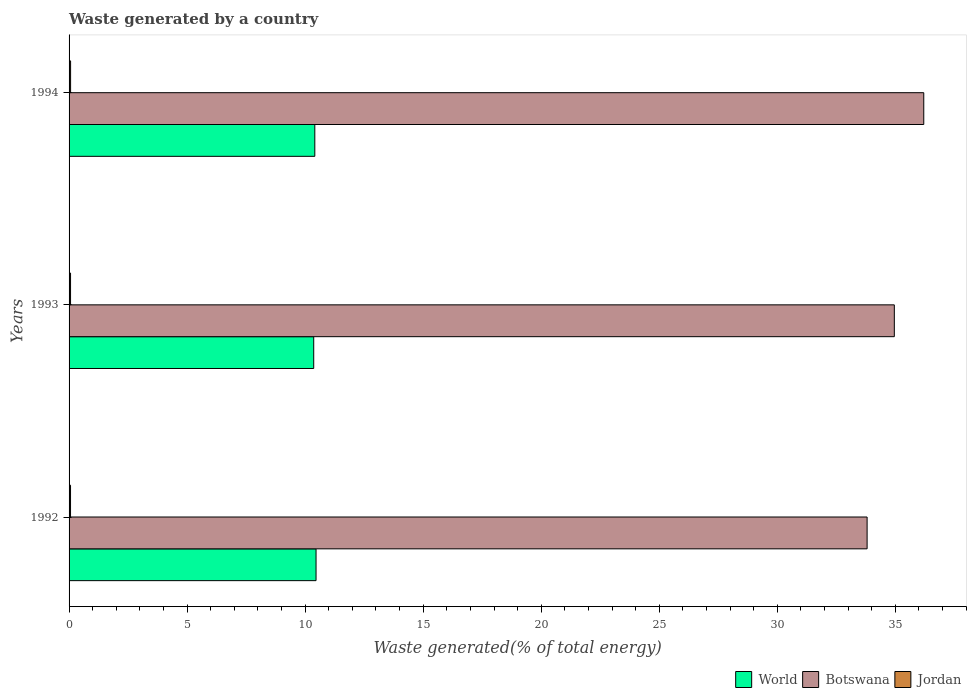Are the number of bars on each tick of the Y-axis equal?
Your answer should be compact. Yes. What is the label of the 2nd group of bars from the top?
Offer a very short reply. 1993. In how many cases, is the number of bars for a given year not equal to the number of legend labels?
Your response must be concise. 0. What is the total waste generated in Jordan in 1992?
Offer a very short reply. 0.06. Across all years, what is the maximum total waste generated in World?
Offer a very short reply. 10.46. Across all years, what is the minimum total waste generated in World?
Ensure brevity in your answer.  10.36. In which year was the total waste generated in Jordan maximum?
Give a very brief answer. 1994. What is the total total waste generated in World in the graph?
Provide a succinct answer. 31.23. What is the difference between the total waste generated in Jordan in 1993 and that in 1994?
Your response must be concise. -0. What is the difference between the total waste generated in Jordan in 1992 and the total waste generated in Botswana in 1993?
Give a very brief answer. -34.89. What is the average total waste generated in Botswana per year?
Offer a very short reply. 34.99. In the year 1994, what is the difference between the total waste generated in Jordan and total waste generated in World?
Make the answer very short. -10.34. What is the ratio of the total waste generated in Botswana in 1993 to that in 1994?
Give a very brief answer. 0.97. Is the total waste generated in Jordan in 1992 less than that in 1994?
Offer a very short reply. Yes. What is the difference between the highest and the second highest total waste generated in Jordan?
Provide a succinct answer. 0. What is the difference between the highest and the lowest total waste generated in World?
Your response must be concise. 0.1. In how many years, is the total waste generated in Botswana greater than the average total waste generated in Botswana taken over all years?
Make the answer very short. 1. What does the 3rd bar from the top in 1993 represents?
Make the answer very short. World. What does the 1st bar from the bottom in 1994 represents?
Make the answer very short. World. Is it the case that in every year, the sum of the total waste generated in World and total waste generated in Botswana is greater than the total waste generated in Jordan?
Offer a terse response. Yes. Are all the bars in the graph horizontal?
Provide a succinct answer. Yes. How many years are there in the graph?
Give a very brief answer. 3. Does the graph contain any zero values?
Make the answer very short. No. How are the legend labels stacked?
Make the answer very short. Horizontal. What is the title of the graph?
Make the answer very short. Waste generated by a country. Does "West Bank and Gaza" appear as one of the legend labels in the graph?
Offer a terse response. No. What is the label or title of the X-axis?
Make the answer very short. Waste generated(% of total energy). What is the label or title of the Y-axis?
Ensure brevity in your answer.  Years. What is the Waste generated(% of total energy) of World in 1992?
Ensure brevity in your answer.  10.46. What is the Waste generated(% of total energy) in Botswana in 1992?
Keep it short and to the point. 33.8. What is the Waste generated(% of total energy) in Jordan in 1992?
Offer a terse response. 0.06. What is the Waste generated(% of total energy) of World in 1993?
Keep it short and to the point. 10.36. What is the Waste generated(% of total energy) in Botswana in 1993?
Provide a succinct answer. 34.96. What is the Waste generated(% of total energy) in Jordan in 1993?
Your answer should be very brief. 0.06. What is the Waste generated(% of total energy) of World in 1994?
Give a very brief answer. 10.41. What is the Waste generated(% of total energy) of Botswana in 1994?
Offer a very short reply. 36.2. What is the Waste generated(% of total energy) of Jordan in 1994?
Your answer should be compact. 0.06. Across all years, what is the maximum Waste generated(% of total energy) of World?
Keep it short and to the point. 10.46. Across all years, what is the maximum Waste generated(% of total energy) of Botswana?
Your answer should be compact. 36.2. Across all years, what is the maximum Waste generated(% of total energy) of Jordan?
Provide a short and direct response. 0.06. Across all years, what is the minimum Waste generated(% of total energy) of World?
Your answer should be very brief. 10.36. Across all years, what is the minimum Waste generated(% of total energy) of Botswana?
Offer a very short reply. 33.8. Across all years, what is the minimum Waste generated(% of total energy) of Jordan?
Your answer should be compact. 0.06. What is the total Waste generated(% of total energy) in World in the graph?
Provide a short and direct response. 31.23. What is the total Waste generated(% of total energy) of Botswana in the graph?
Provide a succinct answer. 104.96. What is the total Waste generated(% of total energy) in Jordan in the graph?
Keep it short and to the point. 0.19. What is the difference between the Waste generated(% of total energy) in World in 1992 and that in 1993?
Make the answer very short. 0.1. What is the difference between the Waste generated(% of total energy) in Botswana in 1992 and that in 1993?
Make the answer very short. -1.15. What is the difference between the Waste generated(% of total energy) of Jordan in 1992 and that in 1993?
Keep it short and to the point. -0. What is the difference between the Waste generated(% of total energy) in World in 1992 and that in 1994?
Make the answer very short. 0.05. What is the difference between the Waste generated(% of total energy) of Botswana in 1992 and that in 1994?
Your answer should be compact. -2.4. What is the difference between the Waste generated(% of total energy) in Jordan in 1992 and that in 1994?
Make the answer very short. -0. What is the difference between the Waste generated(% of total energy) of World in 1993 and that in 1994?
Offer a terse response. -0.05. What is the difference between the Waste generated(% of total energy) in Botswana in 1993 and that in 1994?
Your answer should be very brief. -1.25. What is the difference between the Waste generated(% of total energy) of Jordan in 1993 and that in 1994?
Give a very brief answer. -0. What is the difference between the Waste generated(% of total energy) of World in 1992 and the Waste generated(% of total energy) of Botswana in 1993?
Offer a very short reply. -24.49. What is the difference between the Waste generated(% of total energy) of World in 1992 and the Waste generated(% of total energy) of Jordan in 1993?
Keep it short and to the point. 10.4. What is the difference between the Waste generated(% of total energy) in Botswana in 1992 and the Waste generated(% of total energy) in Jordan in 1993?
Your answer should be very brief. 33.74. What is the difference between the Waste generated(% of total energy) of World in 1992 and the Waste generated(% of total energy) of Botswana in 1994?
Offer a terse response. -25.74. What is the difference between the Waste generated(% of total energy) of World in 1992 and the Waste generated(% of total energy) of Jordan in 1994?
Your answer should be compact. 10.4. What is the difference between the Waste generated(% of total energy) in Botswana in 1992 and the Waste generated(% of total energy) in Jordan in 1994?
Offer a terse response. 33.74. What is the difference between the Waste generated(% of total energy) in World in 1993 and the Waste generated(% of total energy) in Botswana in 1994?
Provide a short and direct response. -25.84. What is the difference between the Waste generated(% of total energy) in World in 1993 and the Waste generated(% of total energy) in Jordan in 1994?
Ensure brevity in your answer.  10.3. What is the difference between the Waste generated(% of total energy) of Botswana in 1993 and the Waste generated(% of total energy) of Jordan in 1994?
Your answer should be compact. 34.89. What is the average Waste generated(% of total energy) in World per year?
Ensure brevity in your answer.  10.41. What is the average Waste generated(% of total energy) of Botswana per year?
Make the answer very short. 34.99. What is the average Waste generated(% of total energy) of Jordan per year?
Make the answer very short. 0.06. In the year 1992, what is the difference between the Waste generated(% of total energy) of World and Waste generated(% of total energy) of Botswana?
Make the answer very short. -23.34. In the year 1992, what is the difference between the Waste generated(% of total energy) in World and Waste generated(% of total energy) in Jordan?
Keep it short and to the point. 10.4. In the year 1992, what is the difference between the Waste generated(% of total energy) of Botswana and Waste generated(% of total energy) of Jordan?
Offer a terse response. 33.74. In the year 1993, what is the difference between the Waste generated(% of total energy) of World and Waste generated(% of total energy) of Botswana?
Your answer should be compact. -24.59. In the year 1993, what is the difference between the Waste generated(% of total energy) in World and Waste generated(% of total energy) in Jordan?
Provide a succinct answer. 10.3. In the year 1993, what is the difference between the Waste generated(% of total energy) in Botswana and Waste generated(% of total energy) in Jordan?
Provide a short and direct response. 34.89. In the year 1994, what is the difference between the Waste generated(% of total energy) in World and Waste generated(% of total energy) in Botswana?
Your answer should be very brief. -25.79. In the year 1994, what is the difference between the Waste generated(% of total energy) in World and Waste generated(% of total energy) in Jordan?
Your answer should be compact. 10.34. In the year 1994, what is the difference between the Waste generated(% of total energy) in Botswana and Waste generated(% of total energy) in Jordan?
Offer a terse response. 36.14. What is the ratio of the Waste generated(% of total energy) in World in 1992 to that in 1993?
Give a very brief answer. 1.01. What is the ratio of the Waste generated(% of total energy) of Botswana in 1992 to that in 1993?
Your answer should be compact. 0.97. What is the ratio of the Waste generated(% of total energy) in Jordan in 1992 to that in 1993?
Offer a terse response. 0.99. What is the ratio of the Waste generated(% of total energy) of Botswana in 1992 to that in 1994?
Keep it short and to the point. 0.93. What is the ratio of the Waste generated(% of total energy) of Jordan in 1992 to that in 1994?
Provide a succinct answer. 0.96. What is the ratio of the Waste generated(% of total energy) of World in 1993 to that in 1994?
Your answer should be very brief. 1. What is the ratio of the Waste generated(% of total energy) in Botswana in 1993 to that in 1994?
Keep it short and to the point. 0.97. What is the ratio of the Waste generated(% of total energy) of Jordan in 1993 to that in 1994?
Your answer should be compact. 0.97. What is the difference between the highest and the second highest Waste generated(% of total energy) of World?
Make the answer very short. 0.05. What is the difference between the highest and the second highest Waste generated(% of total energy) of Botswana?
Provide a short and direct response. 1.25. What is the difference between the highest and the second highest Waste generated(% of total energy) in Jordan?
Offer a terse response. 0. What is the difference between the highest and the lowest Waste generated(% of total energy) of World?
Provide a short and direct response. 0.1. What is the difference between the highest and the lowest Waste generated(% of total energy) of Botswana?
Provide a short and direct response. 2.4. What is the difference between the highest and the lowest Waste generated(% of total energy) in Jordan?
Provide a short and direct response. 0. 